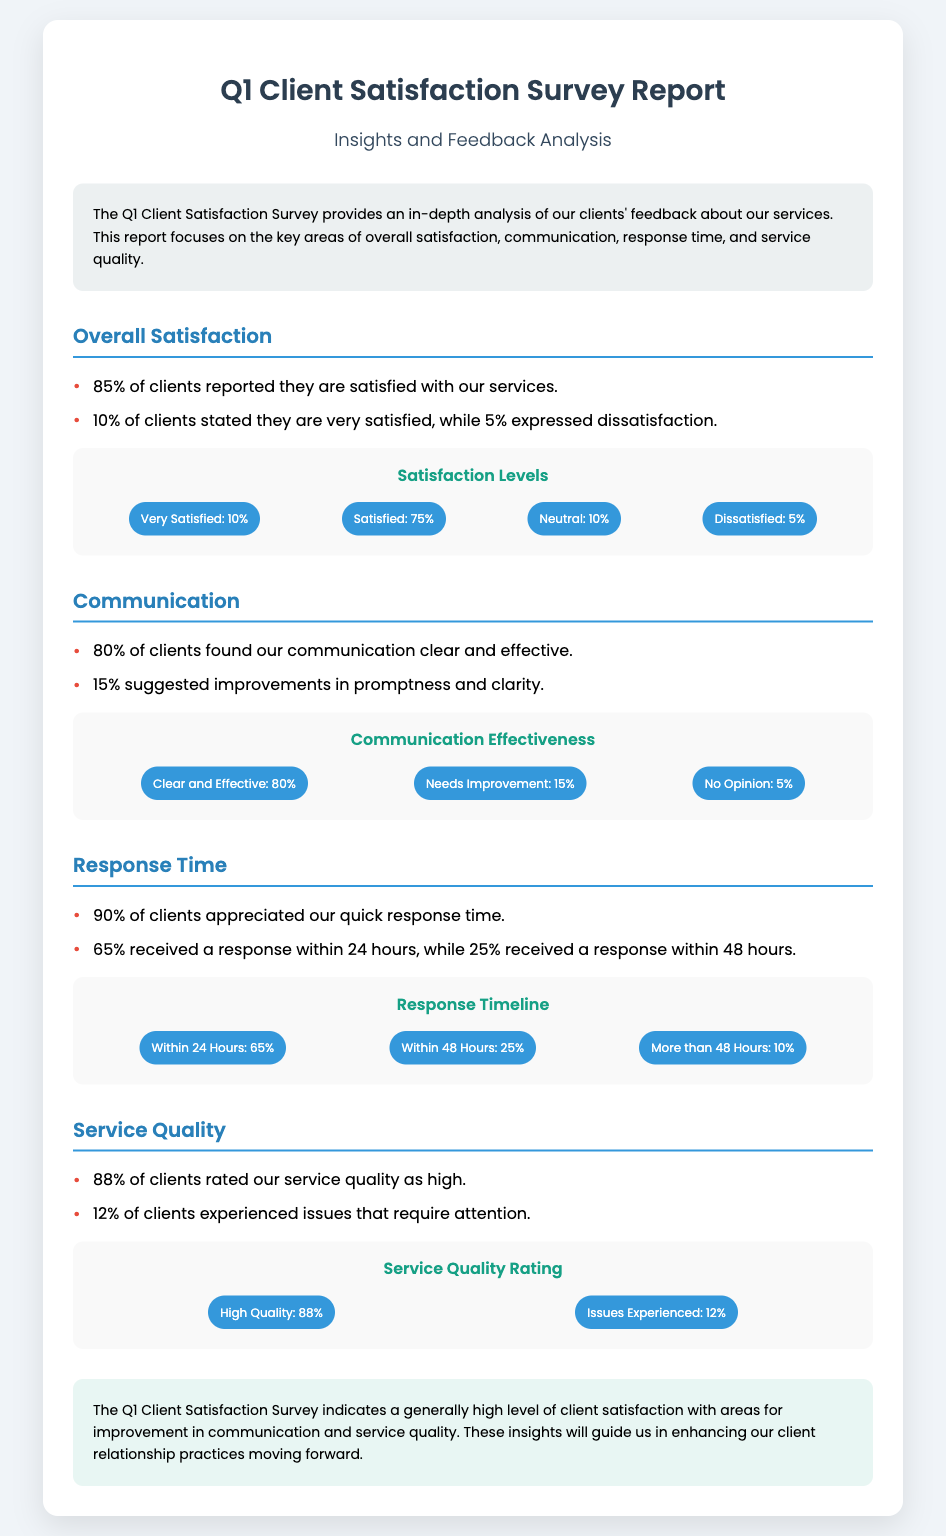what percentage of clients are satisfied with services? The document states that 85% of clients reported satisfaction with the services provided.
Answer: 85% what percentage of clients found communication clear and effective? According to the survey, 80% of clients found the communication to be clear and effective.
Answer: 80% how many clients experienced issues with service quality? The report mentions that 12% of clients experienced issues that require attention.
Answer: 12% what is the main focus of the Q1 Client Satisfaction Survey Report? The report focuses on areas such as overall satisfaction, communication, response time, and service quality.
Answer: Service quality what percentage of clients received a response within 24 hours? The document indicates that 65% of clients received a response within 24 hours.
Answer: 65% what is the overall level of client satisfaction indicated by the survey? The survey indicates a generally high level of client satisfaction, with some areas needing improvement.
Answer: High satisfaction what is the significance of the infographic section in the report? The infographic section visually represents key data points regarding client feedback and areas of interest.
Answer: Visual data representation what conclusion is drawn from the Q1 Client Satisfaction Survey? The conclusion indicates that there is a generally high level of client satisfaction with areas for improvement identified in communication and service quality.
Answer: Areas for improvement 